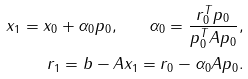Convert formula to latex. <formula><loc_0><loc_0><loc_500><loc_500>x _ { 1 } = x _ { 0 } + \alpha _ { 0 } p _ { 0 } , \quad \alpha _ { 0 } = \frac { r _ { 0 } ^ { T } p _ { 0 } } { p _ { 0 } ^ { T } A p _ { 0 } } , \\ r _ { 1 } = b - A x _ { 1 } = r _ { 0 } - \alpha _ { 0 } A p _ { 0 } .</formula> 